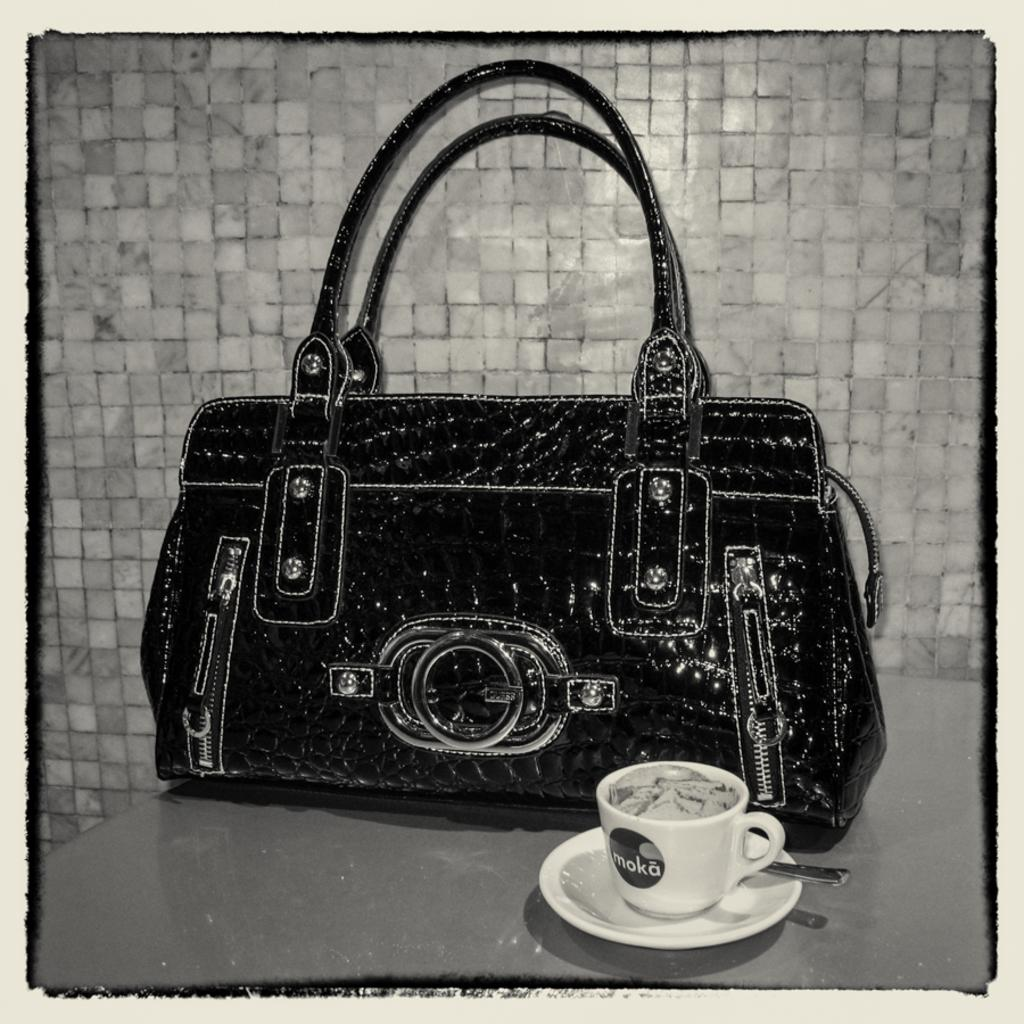What object in the image is typically used for carrying items? There is a bag in the image, which is typically used for carrying items. What object in the image is typically used for holding liquids? There is a cup in the image, which is typically used for holding liquids. What object in the image is typically used as a base for a cup? There is a saucer in the image, which is typically used as a base for a cup. How does the bag crush the bait in the image? There is no bait present in the image, and the bag does not crush anything. What type of fish can be seen pulling the saucer in the image? There are no fish or any object being pulled by a saucer in the image. 